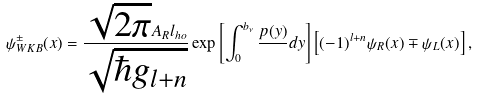Convert formula to latex. <formula><loc_0><loc_0><loc_500><loc_500>\psi _ { W K B } ^ { \pm } ( x ) = \frac { \sqrt { 2 \pi } A _ { R } l _ { h o } } { \sqrt { \hbar { g } _ { l + n } } } \exp \left [ \int _ { 0 } ^ { b _ { \nu } } \frac { p ( y ) } { } d y \right ] \left [ ( - 1 ) ^ { l + n } \psi _ { R } ( x ) \mp \psi _ { L } ( x ) \right ] ,</formula> 